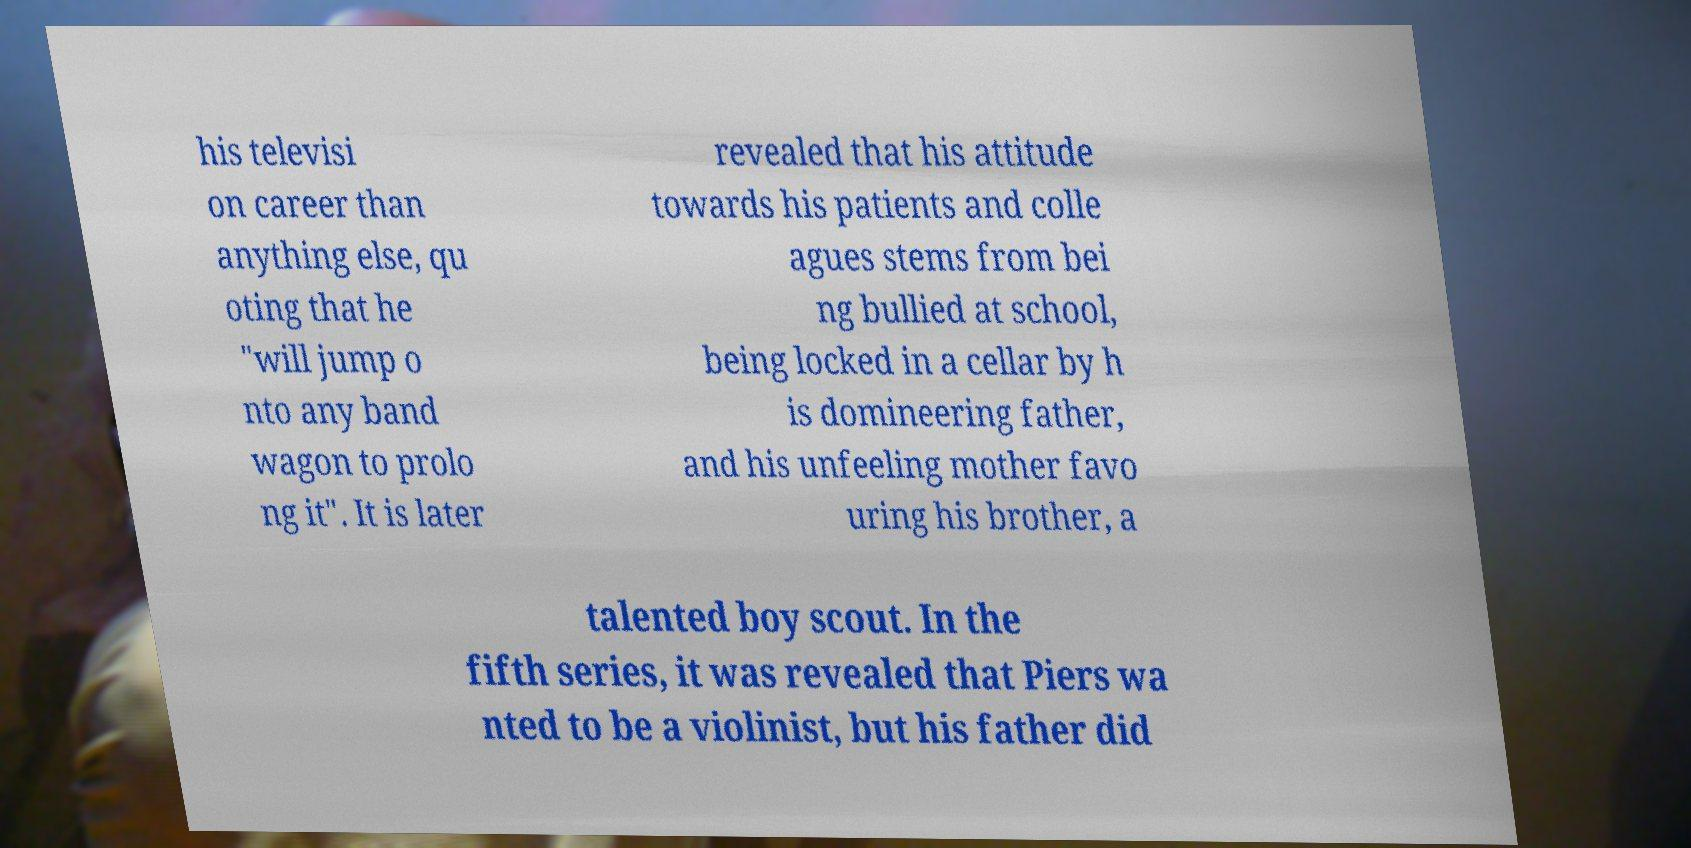What messages or text are displayed in this image? I need them in a readable, typed format. his televisi on career than anything else, qu oting that he "will jump o nto any band wagon to prolo ng it". It is later revealed that his attitude towards his patients and colle agues stems from bei ng bullied at school, being locked in a cellar by h is domineering father, and his unfeeling mother favo uring his brother, a talented boy scout. In the fifth series, it was revealed that Piers wa nted to be a violinist, but his father did 